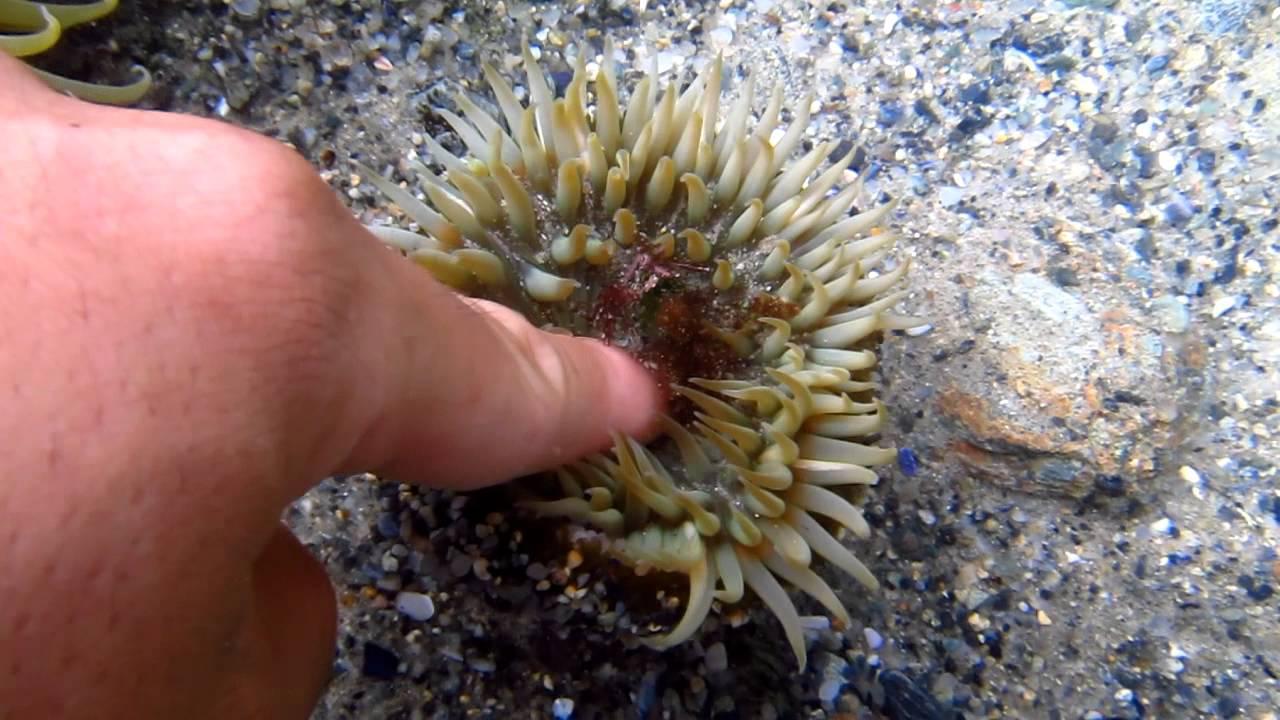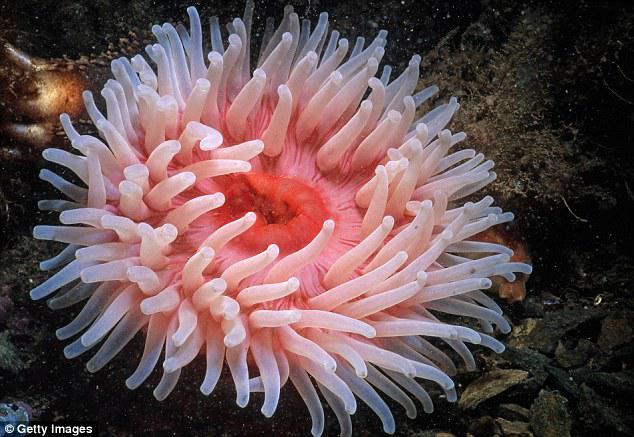The first image is the image on the left, the second image is the image on the right. Assess this claim about the two images: "An image shows one anemone with ombre-toned reddish-tipped tendrils and a yellow center.". Correct or not? Answer yes or no. No. 